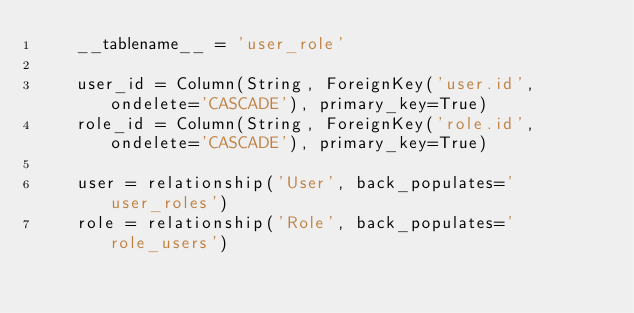<code> <loc_0><loc_0><loc_500><loc_500><_Python_>    __tablename__ = 'user_role'

    user_id = Column(String, ForeignKey('user.id', ondelete='CASCADE'), primary_key=True)
    role_id = Column(String, ForeignKey('role.id', ondelete='CASCADE'), primary_key=True)

    user = relationship('User', back_populates='user_roles')
    role = relationship('Role', back_populates='role_users')
</code> 